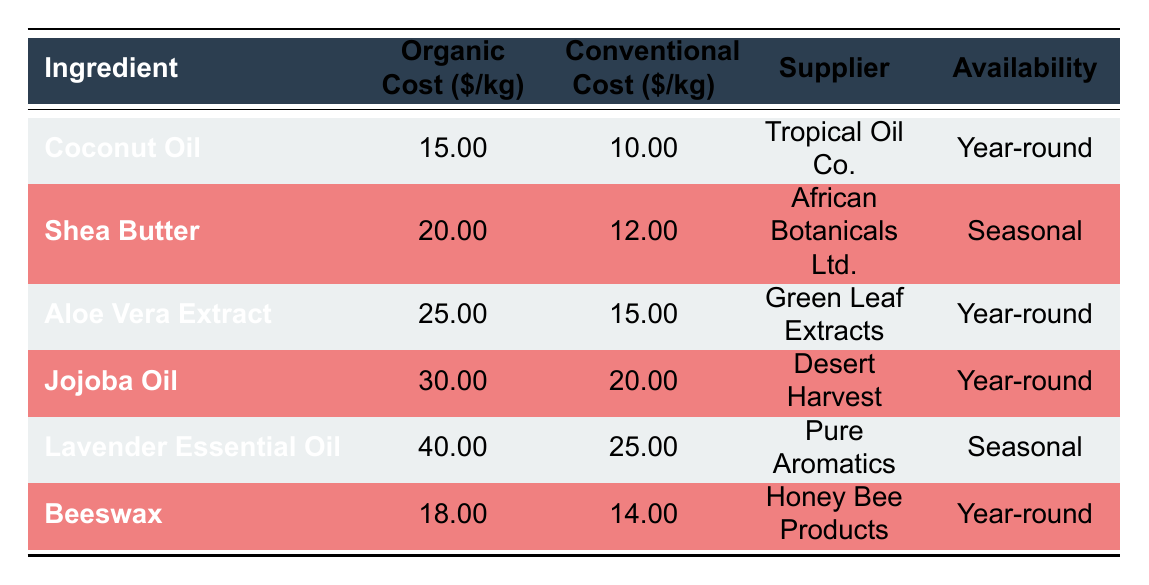What is the cost of organic Aloe Vera Extract per kg? The table shows the organic cost per kg for Aloe Vera Extract specifically listed under the "Organic Cost" column. That value is 25.00.
Answer: 25.00 Which ingredient has the highest conventional cost per kg? By examining the "Conventional Cost" column and comparing the costs, Lavender Essential Oil has the highest cost at 25.00.
Answer: Lavender Essential Oil Is Jojoba Oil available year-round? Jojoba Oil's availability listed in the table is "Year-round," indicating it can be sourced at any time of the year.
Answer: Yes What is the difference in price between organic and conventional Coconut Oil? The table provides the organic cost for Coconut Oil as 15.00 and the conventional cost as 10.00. The difference is calculated as 15.00 - 10.00 = 5.00.
Answer: 5.00 What is the average organic cost for all ingredients listed in the table? The organic costs for all ingredients are 15.00 (Coconut Oil), 20.00 (Shea Butter), 25.00 (Aloe Vera Extract), 30.00 (Jojoba Oil), 40.00 (Lavender Essential Oil), and 18.00 (Beeswax). Summing these gives 15.00 + 20.00 + 25.00 + 30.00 + 40.00 + 18.00 = 148.00. The average is then calculated by dividing this sum by the number of ingredients (6), which equals 148.00 / 6 = approximately 24.67.
Answer: 24.67 Are there any ingredients that are both organic and conventional with the same supplier? Reviewing the table, each ingredient lists a unique supplier. There are no ingredients with the same supplier for both organic and conventional sources.
Answer: No 